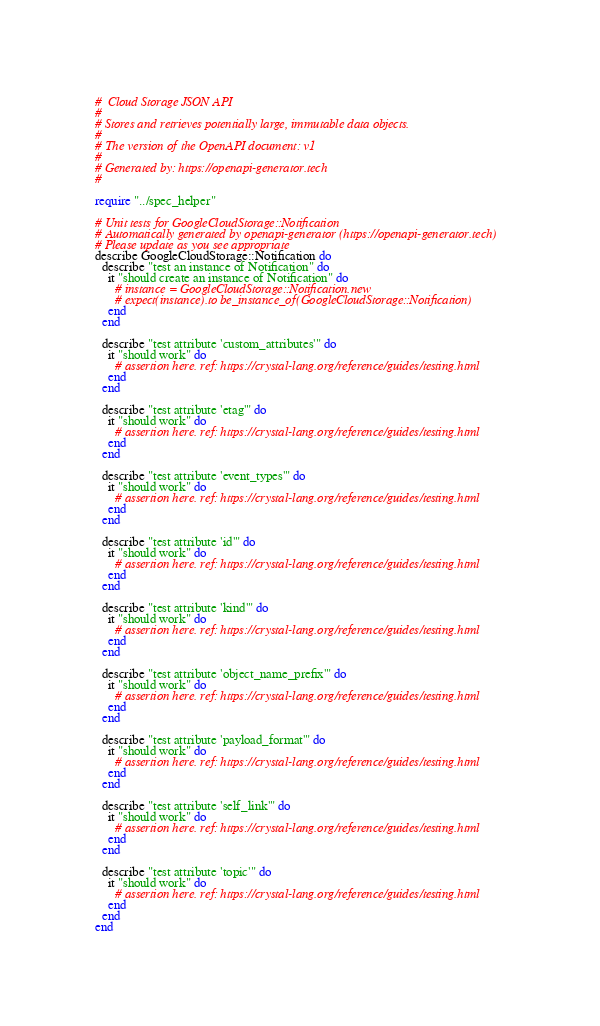Convert code to text. <code><loc_0><loc_0><loc_500><loc_500><_Crystal_>#  Cloud Storage JSON API
#
# Stores and retrieves potentially large, immutable data objects.
#
# The version of the OpenAPI document: v1
#
# Generated by: https://openapi-generator.tech
#

require "../spec_helper"

# Unit tests for GoogleCloudStorage::Notification
# Automatically generated by openapi-generator (https://openapi-generator.tech)
# Please update as you see appropriate
describe GoogleCloudStorage::Notification do
  describe "test an instance of Notification" do
    it "should create an instance of Notification" do
      # instance = GoogleCloudStorage::Notification.new
      # expect(instance).to be_instance_of(GoogleCloudStorage::Notification)
    end
  end

  describe "test attribute 'custom_attributes'" do
    it "should work" do
      # assertion here. ref: https://crystal-lang.org/reference/guides/testing.html
    end
  end

  describe "test attribute 'etag'" do
    it "should work" do
      # assertion here. ref: https://crystal-lang.org/reference/guides/testing.html
    end
  end

  describe "test attribute 'event_types'" do
    it "should work" do
      # assertion here. ref: https://crystal-lang.org/reference/guides/testing.html
    end
  end

  describe "test attribute 'id'" do
    it "should work" do
      # assertion here. ref: https://crystal-lang.org/reference/guides/testing.html
    end
  end

  describe "test attribute 'kind'" do
    it "should work" do
      # assertion here. ref: https://crystal-lang.org/reference/guides/testing.html
    end
  end

  describe "test attribute 'object_name_prefix'" do
    it "should work" do
      # assertion here. ref: https://crystal-lang.org/reference/guides/testing.html
    end
  end

  describe "test attribute 'payload_format'" do
    it "should work" do
      # assertion here. ref: https://crystal-lang.org/reference/guides/testing.html
    end
  end

  describe "test attribute 'self_link'" do
    it "should work" do
      # assertion here. ref: https://crystal-lang.org/reference/guides/testing.html
    end
  end

  describe "test attribute 'topic'" do
    it "should work" do
      # assertion here. ref: https://crystal-lang.org/reference/guides/testing.html
    end
  end
end
</code> 